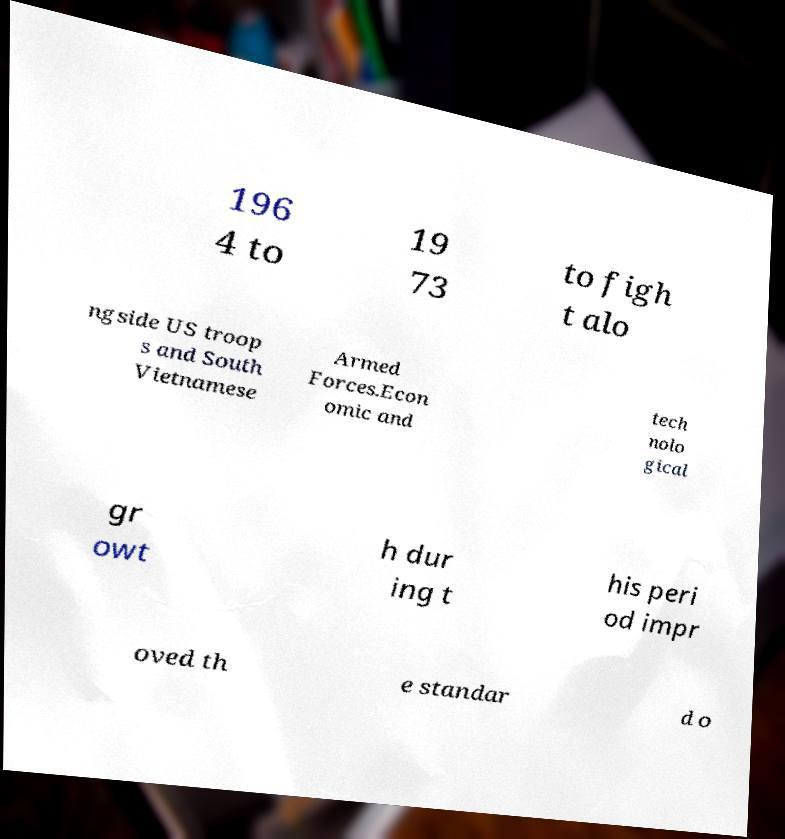I need the written content from this picture converted into text. Can you do that? 196 4 to 19 73 to figh t alo ngside US troop s and South Vietnamese Armed Forces.Econ omic and tech nolo gical gr owt h dur ing t his peri od impr oved th e standar d o 